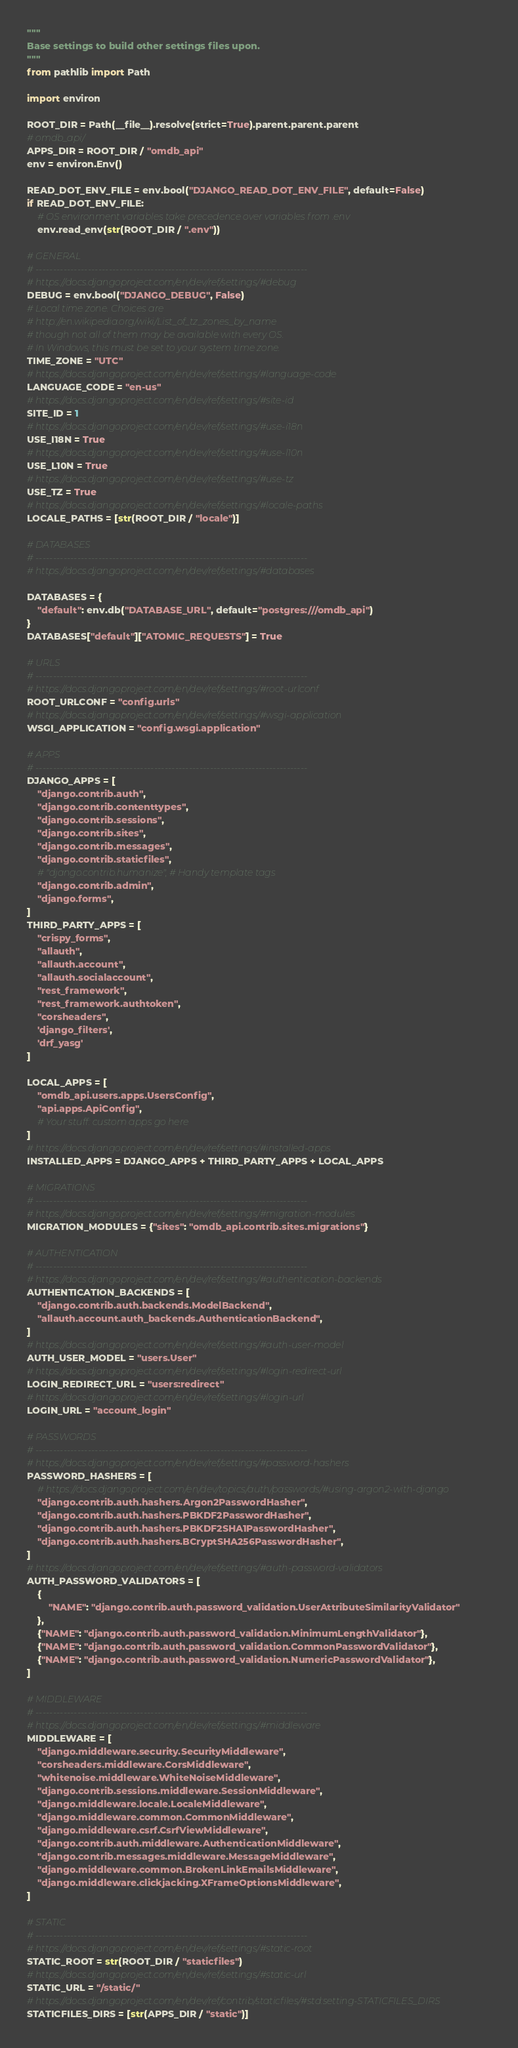<code> <loc_0><loc_0><loc_500><loc_500><_Python_>"""
Base settings to build other settings files upon.
"""
from pathlib import Path

import environ

ROOT_DIR = Path(__file__).resolve(strict=True).parent.parent.parent
# omdb_api/
APPS_DIR = ROOT_DIR / "omdb_api"
env = environ.Env()

READ_DOT_ENV_FILE = env.bool("DJANGO_READ_DOT_ENV_FILE", default=False)
if READ_DOT_ENV_FILE:
    # OS environment variables take precedence over variables from .env
    env.read_env(str(ROOT_DIR / ".env"))

# GENERAL
# ------------------------------------------------------------------------------
# https://docs.djangoproject.com/en/dev/ref/settings/#debug
DEBUG = env.bool("DJANGO_DEBUG", False)
# Local time zone. Choices are
# http://en.wikipedia.org/wiki/List_of_tz_zones_by_name
# though not all of them may be available with every OS.
# In Windows, this must be set to your system time zone.
TIME_ZONE = "UTC"
# https://docs.djangoproject.com/en/dev/ref/settings/#language-code
LANGUAGE_CODE = "en-us"
# https://docs.djangoproject.com/en/dev/ref/settings/#site-id
SITE_ID = 1
# https://docs.djangoproject.com/en/dev/ref/settings/#use-i18n
USE_I18N = True
# https://docs.djangoproject.com/en/dev/ref/settings/#use-l10n
USE_L10N = True
# https://docs.djangoproject.com/en/dev/ref/settings/#use-tz
USE_TZ = True
# https://docs.djangoproject.com/en/dev/ref/settings/#locale-paths
LOCALE_PATHS = [str(ROOT_DIR / "locale")]

# DATABASES
# ------------------------------------------------------------------------------
# https://docs.djangoproject.com/en/dev/ref/settings/#databases

DATABASES = {
    "default": env.db("DATABASE_URL", default="postgres:///omdb_api")
}
DATABASES["default"]["ATOMIC_REQUESTS"] = True

# URLS
# ------------------------------------------------------------------------------
# https://docs.djangoproject.com/en/dev/ref/settings/#root-urlconf
ROOT_URLCONF = "config.urls"
# https://docs.djangoproject.com/en/dev/ref/settings/#wsgi-application
WSGI_APPLICATION = "config.wsgi.application"

# APPS
# ------------------------------------------------------------------------------
DJANGO_APPS = [
    "django.contrib.auth",
    "django.contrib.contenttypes",
    "django.contrib.sessions",
    "django.contrib.sites",
    "django.contrib.messages",
    "django.contrib.staticfiles",
    # "django.contrib.humanize", # Handy template tags
    "django.contrib.admin",
    "django.forms",
]
THIRD_PARTY_APPS = [
    "crispy_forms",
    "allauth",
    "allauth.account",
    "allauth.socialaccount",
    "rest_framework",
    "rest_framework.authtoken",
    "corsheaders",
    'django_filters',
    'drf_yasg'
]

LOCAL_APPS = [
    "omdb_api.users.apps.UsersConfig",
    "api.apps.ApiConfig",
    # Your stuff: custom apps go here
]
# https://docs.djangoproject.com/en/dev/ref/settings/#installed-apps
INSTALLED_APPS = DJANGO_APPS + THIRD_PARTY_APPS + LOCAL_APPS

# MIGRATIONS
# ------------------------------------------------------------------------------
# https://docs.djangoproject.com/en/dev/ref/settings/#migration-modules
MIGRATION_MODULES = {"sites": "omdb_api.contrib.sites.migrations"}

# AUTHENTICATION
# ------------------------------------------------------------------------------
# https://docs.djangoproject.com/en/dev/ref/settings/#authentication-backends
AUTHENTICATION_BACKENDS = [
    "django.contrib.auth.backends.ModelBackend",
    "allauth.account.auth_backends.AuthenticationBackend",
]
# https://docs.djangoproject.com/en/dev/ref/settings/#auth-user-model
AUTH_USER_MODEL = "users.User"
# https://docs.djangoproject.com/en/dev/ref/settings/#login-redirect-url
LOGIN_REDIRECT_URL = "users:redirect"
# https://docs.djangoproject.com/en/dev/ref/settings/#login-url
LOGIN_URL = "account_login"

# PASSWORDS
# ------------------------------------------------------------------------------
# https://docs.djangoproject.com/en/dev/ref/settings/#password-hashers
PASSWORD_HASHERS = [
    # https://docs.djangoproject.com/en/dev/topics/auth/passwords/#using-argon2-with-django
    "django.contrib.auth.hashers.Argon2PasswordHasher",
    "django.contrib.auth.hashers.PBKDF2PasswordHasher",
    "django.contrib.auth.hashers.PBKDF2SHA1PasswordHasher",
    "django.contrib.auth.hashers.BCryptSHA256PasswordHasher",
]
# https://docs.djangoproject.com/en/dev/ref/settings/#auth-password-validators
AUTH_PASSWORD_VALIDATORS = [
    {
        "NAME": "django.contrib.auth.password_validation.UserAttributeSimilarityValidator"
    },
    {"NAME": "django.contrib.auth.password_validation.MinimumLengthValidator"},
    {"NAME": "django.contrib.auth.password_validation.CommonPasswordValidator"},
    {"NAME": "django.contrib.auth.password_validation.NumericPasswordValidator"},
]

# MIDDLEWARE
# ------------------------------------------------------------------------------
# https://docs.djangoproject.com/en/dev/ref/settings/#middleware
MIDDLEWARE = [
    "django.middleware.security.SecurityMiddleware",
    "corsheaders.middleware.CorsMiddleware",
    "whitenoise.middleware.WhiteNoiseMiddleware",
    "django.contrib.sessions.middleware.SessionMiddleware",
    "django.middleware.locale.LocaleMiddleware",
    "django.middleware.common.CommonMiddleware",
    "django.middleware.csrf.CsrfViewMiddleware",
    "django.contrib.auth.middleware.AuthenticationMiddleware",
    "django.contrib.messages.middleware.MessageMiddleware",
    "django.middleware.common.BrokenLinkEmailsMiddleware",
    "django.middleware.clickjacking.XFrameOptionsMiddleware",
]

# STATIC
# ------------------------------------------------------------------------------
# https://docs.djangoproject.com/en/dev/ref/settings/#static-root
STATIC_ROOT = str(ROOT_DIR / "staticfiles")
# https://docs.djangoproject.com/en/dev/ref/settings/#static-url
STATIC_URL = "/static/"
# https://docs.djangoproject.com/en/dev/ref/contrib/staticfiles/#std:setting-STATICFILES_DIRS
STATICFILES_DIRS = [str(APPS_DIR / "static")]</code> 